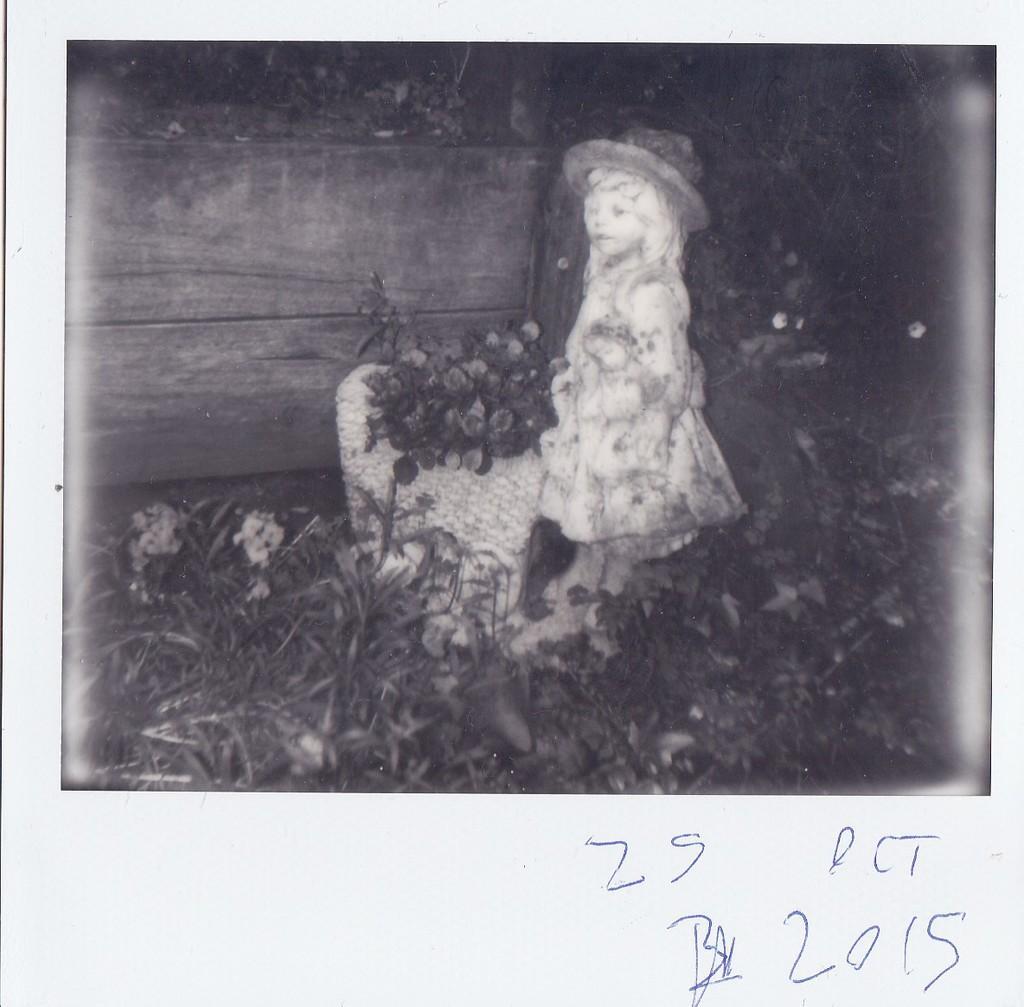How would you summarize this image in a sentence or two? In the center of the image there is a girl. At the bottom of the image there are plants. There is some text written at the bottom of the image. 